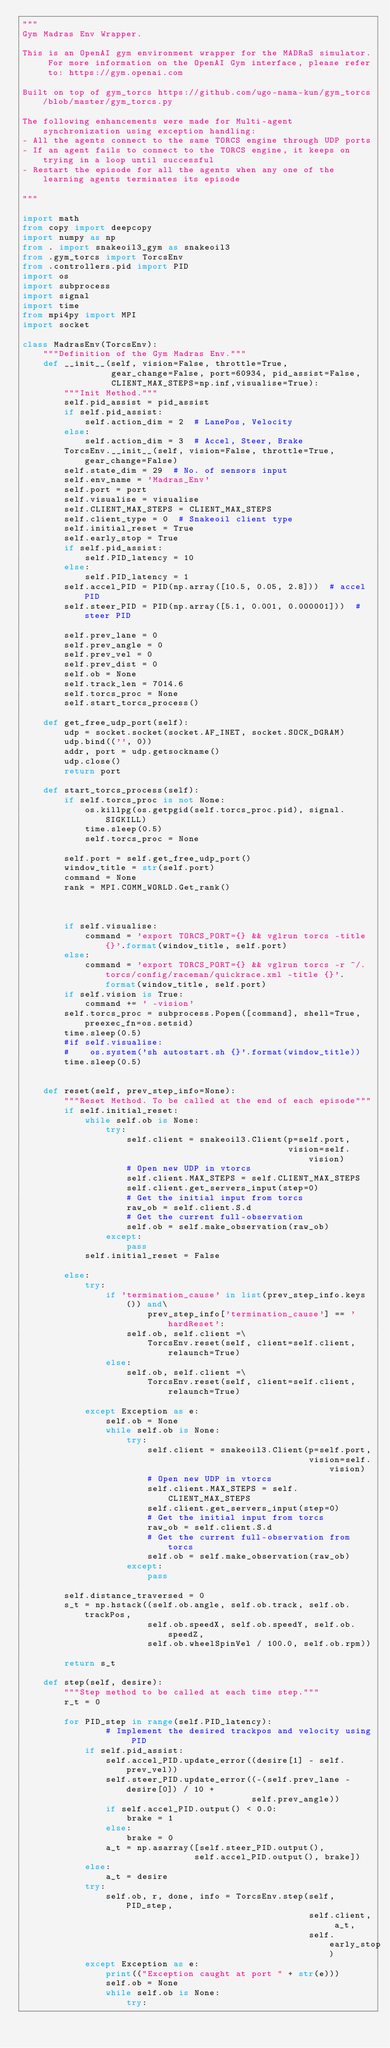<code> <loc_0><loc_0><loc_500><loc_500><_Python_>"""
Gym Madras Env Wrapper.

This is an OpenAI gym environment wrapper for the MADRaS simulator. For more information on the OpenAI Gym interface, please refer to: https://gym.openai.com

Built on top of gym_torcs https://github.com/ugo-nama-kun/gym_torcs/blob/master/gym_torcs.py

The following enhancements were made for Multi-agent synchronization using exception handling:
- All the agents connect to the same TORCS engine through UDP ports
- If an agent fails to connect to the TORCS engine, it keeps on trying in a loop until successful
- Restart the episode for all the agents when any one of the learning agents terminates its episode

"""

import math
from copy import deepcopy
import numpy as np
from . import snakeoil3_gym as snakeoil3
from .gym_torcs import TorcsEnv
from .controllers.pid import PID
import os
import subprocess
import signal
import time
from mpi4py import MPI
import socket

class MadrasEnv(TorcsEnv):
    """Definition of the Gym Madras Env."""
    def __init__(self, vision=False, throttle=True,
                 gear_change=False, port=60934, pid_assist=False,
                 CLIENT_MAX_STEPS=np.inf,visualise=True):
        """Init Method."""
        self.pid_assist = pid_assist
        if self.pid_assist:
            self.action_dim = 2  # LanePos, Velocity
        else:
            self.action_dim = 3  # Accel, Steer, Brake
        TorcsEnv.__init__(self, vision=False, throttle=True, gear_change=False)
        self.state_dim = 29  # No. of sensors input
        self.env_name = 'Madras_Env'
        self.port = port
        self.visualise = visualise
        self.CLIENT_MAX_STEPS = CLIENT_MAX_STEPS
        self.client_type = 0  # Snakeoil client type
        self.initial_reset = True
        self.early_stop = True
        if self.pid_assist:
            self.PID_latency = 10
        else:
            self.PID_latency = 1
        self.accel_PID = PID(np.array([10.5, 0.05, 2.8]))  # accel PID
        self.steer_PID = PID(np.array([5.1, 0.001, 0.000001]))  # steer PID

        self.prev_lane = 0
        self.prev_angle = 0
        self.prev_vel = 0
        self.prev_dist = 0
        self.ob = None
        self.track_len = 7014.6
        self.torcs_proc = None
        self.start_torcs_process()
        
    def get_free_udp_port(self):
        udp = socket.socket(socket.AF_INET, socket.SOCK_DGRAM)
        udp.bind(('', 0))
        addr, port = udp.getsockname()
        udp.close()
        return port

    def start_torcs_process(self):
        if self.torcs_proc is not None:
            os.killpg(os.getpgid(self.torcs_proc.pid), signal.SIGKILL)
            time.sleep(0.5)
            self.torcs_proc = None

        self.port = self.get_free_udp_port()
        window_title = str(self.port)
        command = None
        rank = MPI.COMM_WORLD.Get_rank()

        

        if self.visualise:
            command = 'export TORCS_PORT={} && vglrun torcs -title {}'.format(window_title, self.port)
        else:
            command = 'export TORCS_PORT={} && vglrun torcs -r ~/.torcs/config/raceman/quickrace.xml -title {}'.format(window_title, self.port)
        if self.vision is True:
            command += ' -vision'
        self.torcs_proc = subprocess.Popen([command], shell=True, preexec_fn=os.setsid)
        time.sleep(0.5)
        #if self.visualise:
        #    os.system('sh autostart.sh {}'.format(window_title))
        time.sleep(0.5)

   
    def reset(self, prev_step_info=None):
        """Reset Method. To be called at the end of each episode"""
        if self.initial_reset:
            while self.ob is None:
                try:
                    self.client = snakeoil3.Client(p=self.port,
                                                   vision=self.vision)
                    # Open new UDP in vtorcs
                    self.client.MAX_STEPS = self.CLIENT_MAX_STEPS
                    self.client.get_servers_input(step=0)
                    # Get the initial input from torcs
                    raw_ob = self.client.S.d
                    # Get the current full-observation
                    self.ob = self.make_observation(raw_ob)
                except:
                    pass
            self.initial_reset = False

        else:
            try:
                if 'termination_cause' in list(prev_step_info.keys()) and\
                        prev_step_info['termination_cause'] == 'hardReset':
                    self.ob, self.client =\
                        TorcsEnv.reset(self, client=self.client, relaunch=True)
                else:
                    self.ob, self.client =\
                        TorcsEnv.reset(self, client=self.client, relaunch=True)

            except Exception as e:
                self.ob = None
                while self.ob is None:
                    try:
                        self.client = snakeoil3.Client(p=self.port,
                                                       vision=self.vision)
                        # Open new UDP in vtorcs
                        self.client.MAX_STEPS = self.CLIENT_MAX_STEPS
                        self.client.get_servers_input(step=0)
                        # Get the initial input from torcs
                        raw_ob = self.client.S.d
                        # Get the current full-observation from torcs
                        self.ob = self.make_observation(raw_ob)
                    except:
                        pass

        self.distance_traversed = 0
        s_t = np.hstack((self.ob.angle, self.ob.track, self.ob.trackPos,
                        self.ob.speedX, self.ob.speedY, self.ob.speedZ,
                        self.ob.wheelSpinVel / 100.0, self.ob.rpm))

        return s_t

    def step(self, desire):
        """Step method to be called at each time step."""
        r_t = 0

        for PID_step in range(self.PID_latency):
                # Implement the desired trackpos and velocity using PID
            if self.pid_assist:
                self.accel_PID.update_error((desire[1] - self.prev_vel))
                self.steer_PID.update_error((-(self.prev_lane - desire[0]) / 10 +
                                            self.prev_angle))
                if self.accel_PID.output() < 0.0:
                    brake = 1
                else:
                    brake = 0
                a_t = np.asarray([self.steer_PID.output(),
                                 self.accel_PID.output(), brake])
            else:
                a_t = desire
            try:
                self.ob, r, done, info = TorcsEnv.step(self, PID_step,
                                                       self.client, a_t,
                                                       self.early_stop)
            except Exception as e:
                print(("Exception caught at port " + str(e)))
                self.ob = None
                while self.ob is None:
                    try:</code> 